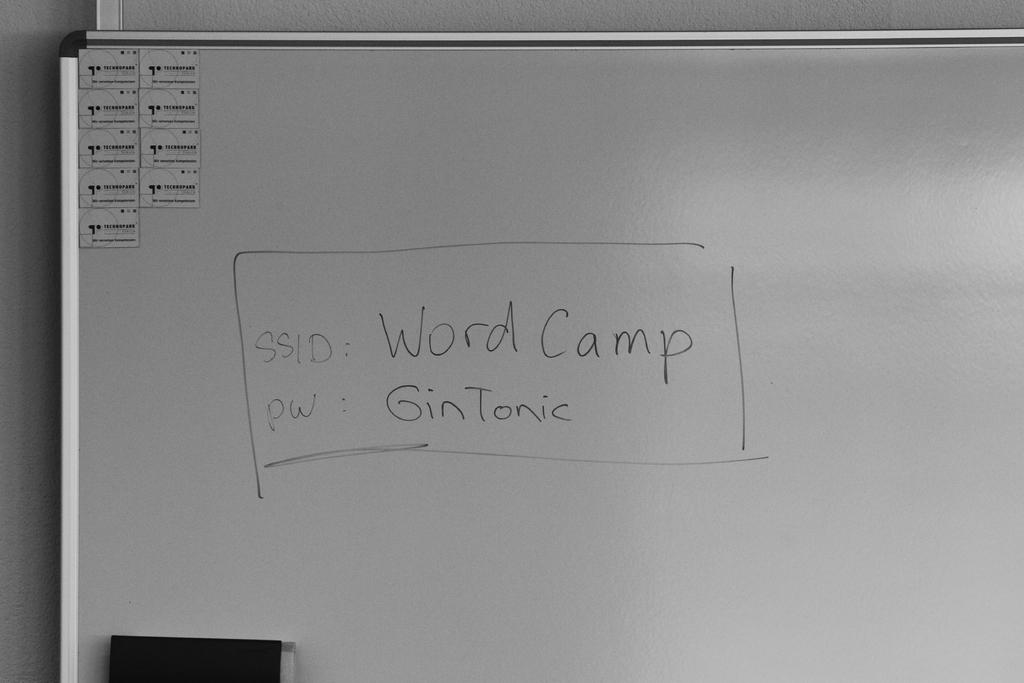Provide a one-sentence caption for the provided image. A whiteboard displays an SSID and password for an account. 